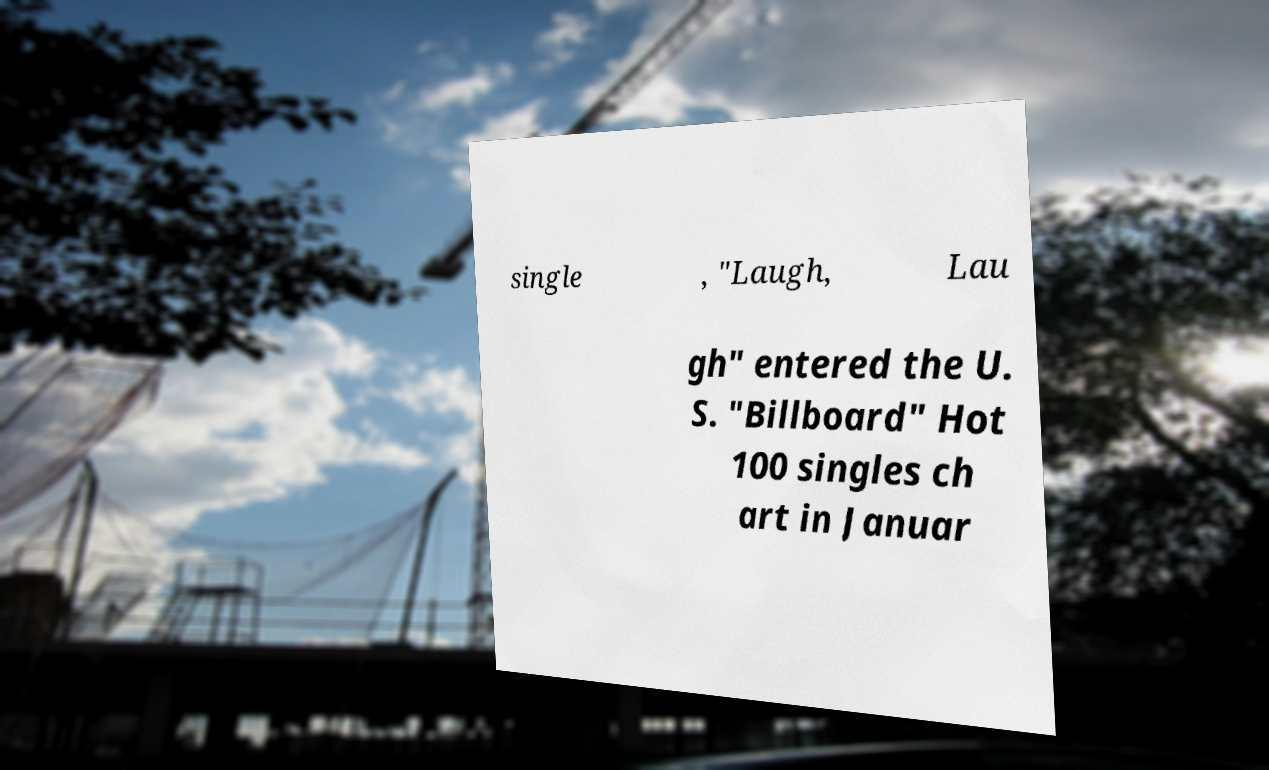There's text embedded in this image that I need extracted. Can you transcribe it verbatim? single , "Laugh, Lau gh" entered the U. S. "Billboard" Hot 100 singles ch art in Januar 